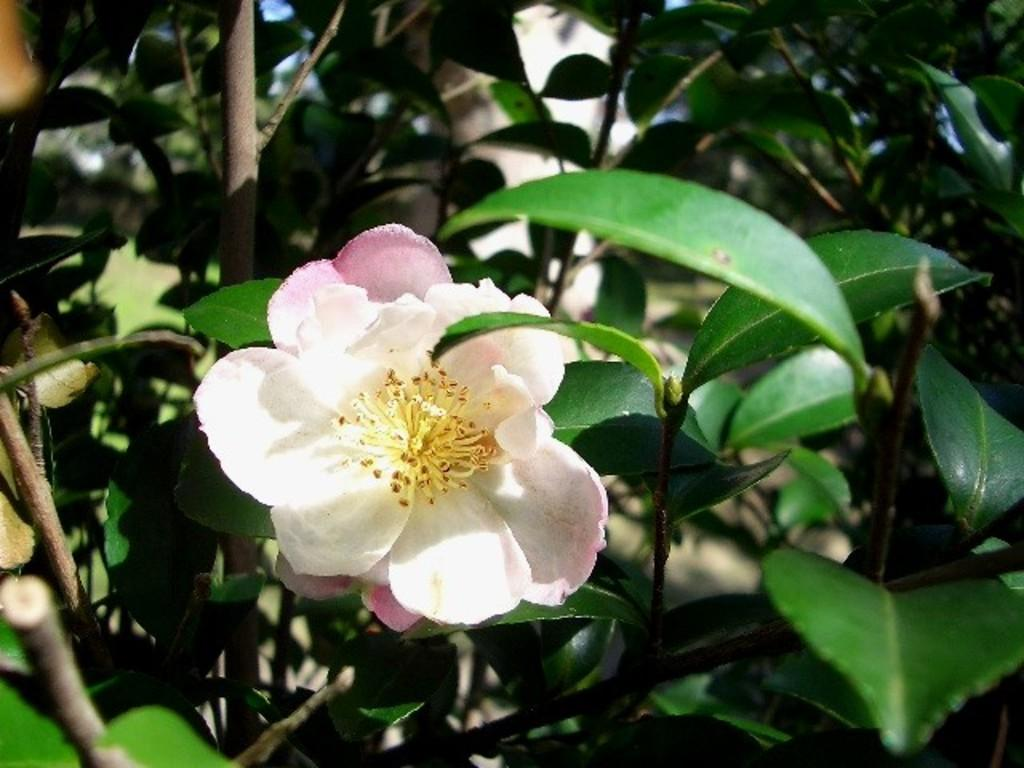What is the main subject of the image? The main subject of the image is a flower. Can you describe the colors of the flower? The flower has yellow, white, and pink colors. What type of trousers is the flower wearing in the image? There are no trousers present in the image, as the subject is a flower. 